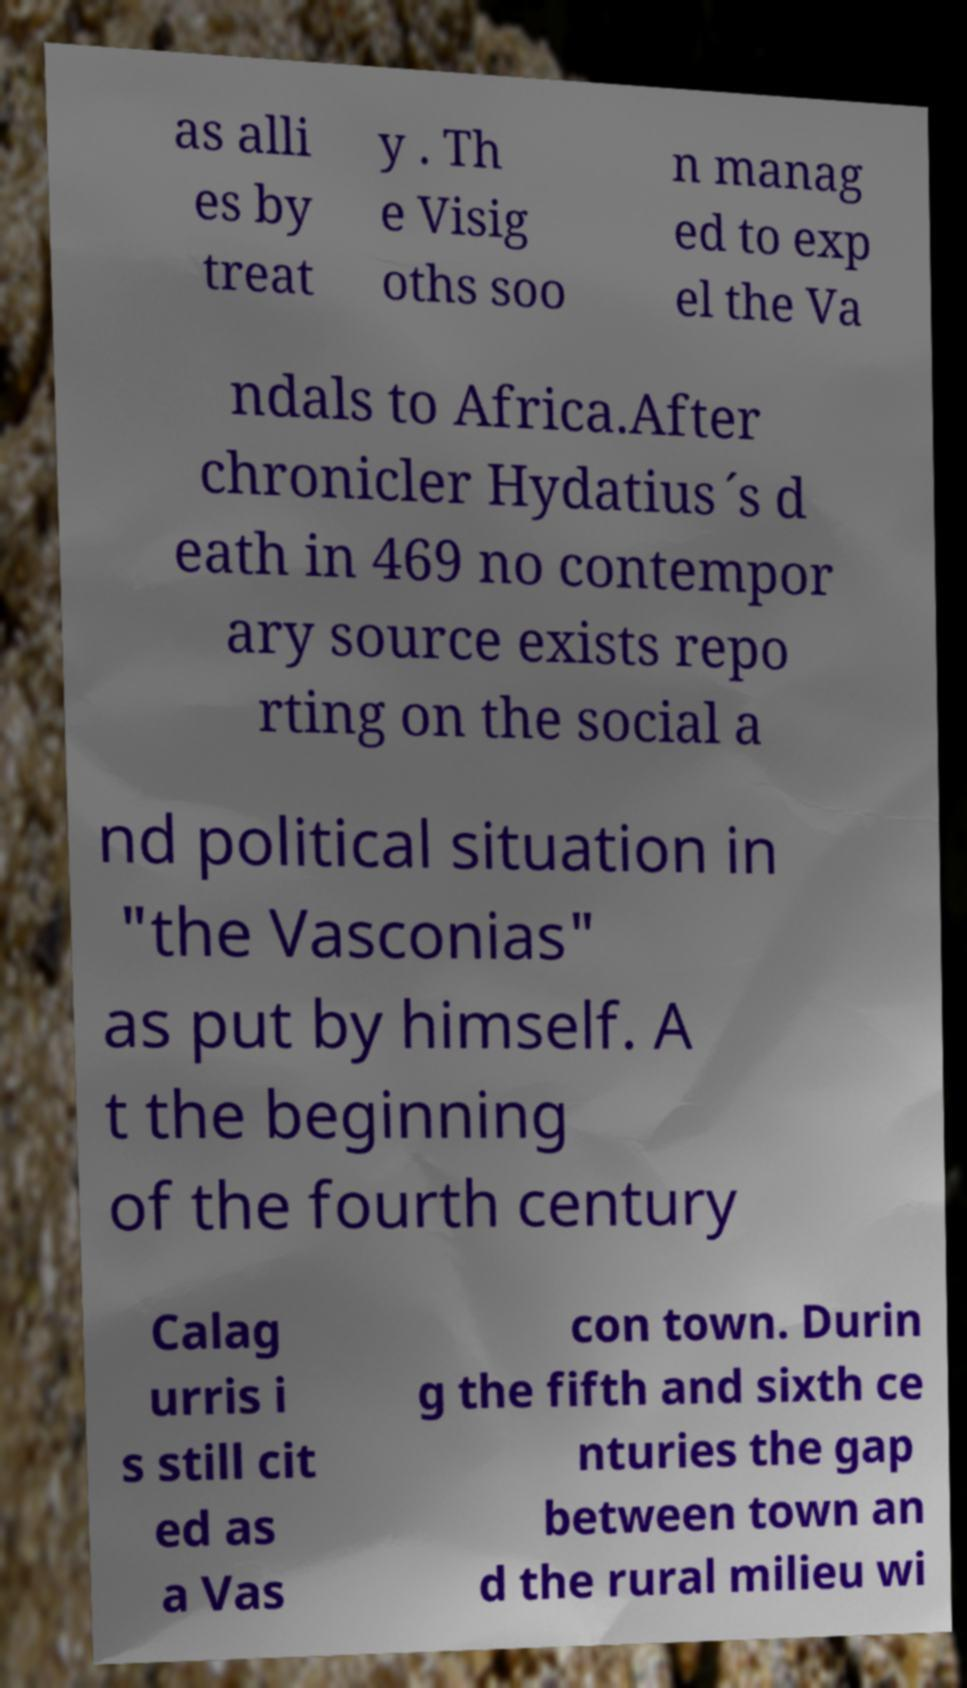Could you extract and type out the text from this image? as alli es by treat y . Th e Visig oths soo n manag ed to exp el the Va ndals to Africa.After chronicler Hydatius´s d eath in 469 no contempor ary source exists repo rting on the social a nd political situation in "the Vasconias" as put by himself. A t the beginning of the fourth century Calag urris i s still cit ed as a Vas con town. Durin g the fifth and sixth ce nturies the gap between town an d the rural milieu wi 